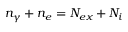Convert formula to latex. <formula><loc_0><loc_0><loc_500><loc_500>n _ { \gamma } + n _ { e } = N _ { e x } + N _ { i }</formula> 